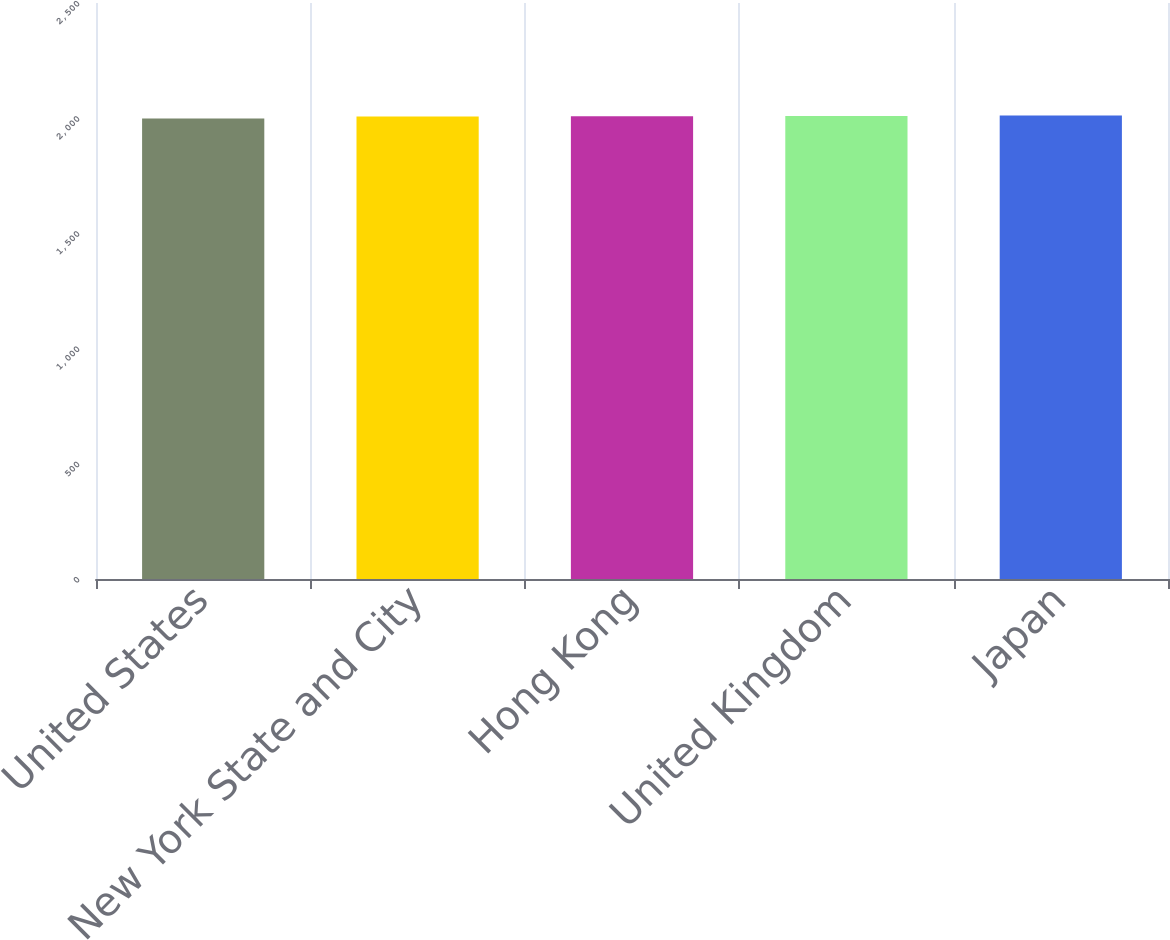Convert chart to OTSL. <chart><loc_0><loc_0><loc_500><loc_500><bar_chart><fcel>United States<fcel>New York State and City<fcel>Hong Kong<fcel>United Kingdom<fcel>Japan<nl><fcel>1999<fcel>2007<fcel>2008.3<fcel>2010<fcel>2012<nl></chart> 